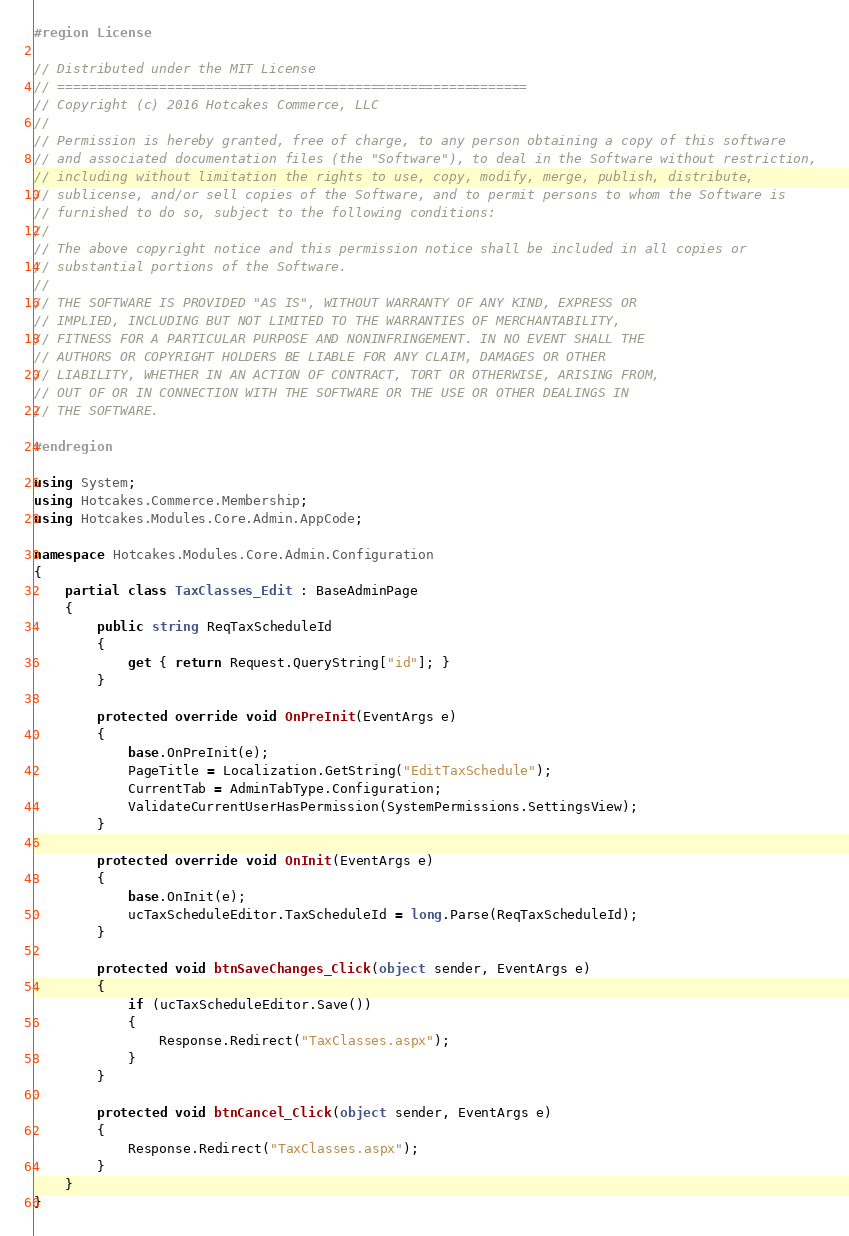Convert code to text. <code><loc_0><loc_0><loc_500><loc_500><_C#_>#region License

// Distributed under the MIT License
// ============================================================
// Copyright (c) 2016 Hotcakes Commerce, LLC
// 
// Permission is hereby granted, free of charge, to any person obtaining a copy of this software 
// and associated documentation files (the "Software"), to deal in the Software without restriction, 
// including without limitation the rights to use, copy, modify, merge, publish, distribute, 
// sublicense, and/or sell copies of the Software, and to permit persons to whom the Software is 
// furnished to do so, subject to the following conditions:
// 
// The above copyright notice and this permission notice shall be included in all copies or 
// substantial portions of the Software.
// 
// THE SOFTWARE IS PROVIDED "AS IS", WITHOUT WARRANTY OF ANY KIND, EXPRESS OR 
// IMPLIED, INCLUDING BUT NOT LIMITED TO THE WARRANTIES OF MERCHANTABILITY, 
// FITNESS FOR A PARTICULAR PURPOSE AND NONINFRINGEMENT. IN NO EVENT SHALL THE 
// AUTHORS OR COPYRIGHT HOLDERS BE LIABLE FOR ANY CLAIM, DAMAGES OR OTHER 
// LIABILITY, WHETHER IN AN ACTION OF CONTRACT, TORT OR OTHERWISE, ARISING FROM, 
// OUT OF OR IN CONNECTION WITH THE SOFTWARE OR THE USE OR OTHER DEALINGS IN 
// THE SOFTWARE.

#endregion

using System;
using Hotcakes.Commerce.Membership;
using Hotcakes.Modules.Core.Admin.AppCode;

namespace Hotcakes.Modules.Core.Admin.Configuration
{
    partial class TaxClasses_Edit : BaseAdminPage
    {
        public string ReqTaxScheduleId
        {
            get { return Request.QueryString["id"]; }
        }

        protected override void OnPreInit(EventArgs e)
        {
            base.OnPreInit(e);
            PageTitle = Localization.GetString("EditTaxSchedule");
            CurrentTab = AdminTabType.Configuration;
            ValidateCurrentUserHasPermission(SystemPermissions.SettingsView);
        }

        protected override void OnInit(EventArgs e)
        {
            base.OnInit(e);
            ucTaxScheduleEditor.TaxScheduleId = long.Parse(ReqTaxScheduleId);
        }

        protected void btnSaveChanges_Click(object sender, EventArgs e)
        {
            if (ucTaxScheduleEditor.Save())
            {
                Response.Redirect("TaxClasses.aspx");
            }
        }

        protected void btnCancel_Click(object sender, EventArgs e)
        {
            Response.Redirect("TaxClasses.aspx");
        }
    }
}</code> 